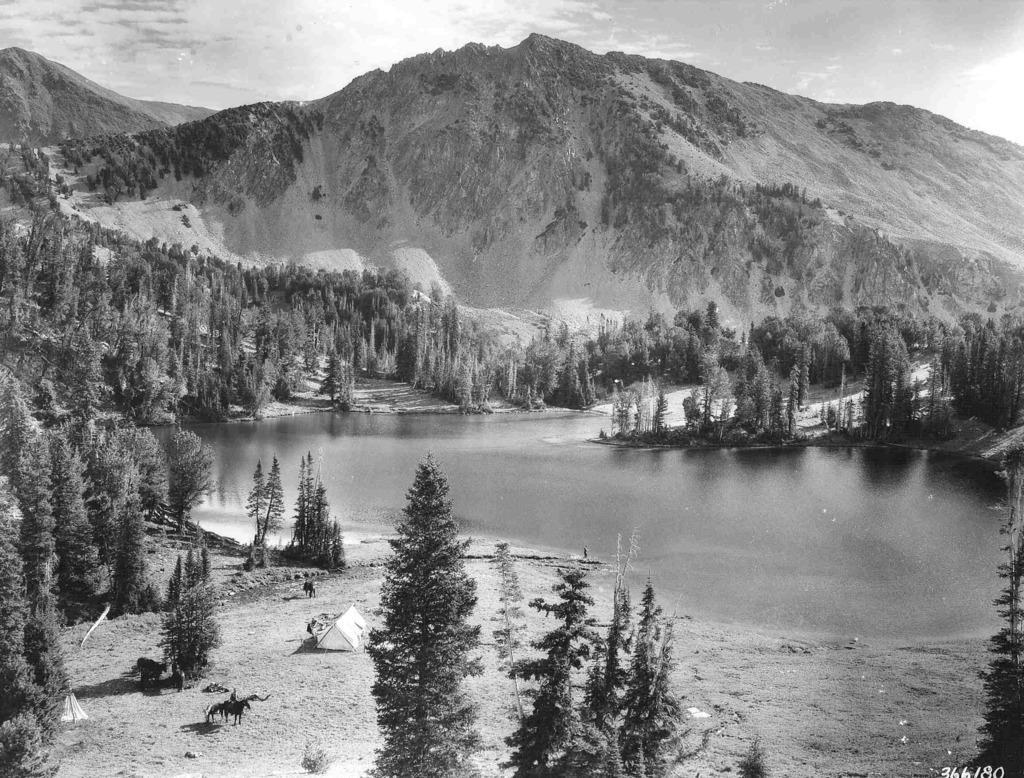How would you summarize this image in a sentence or two? It is a black and white image. In this image we can see the hills, trees, tent, sand and also the water. We can also see the sky. In the bottom right corner we can see the numbers. 